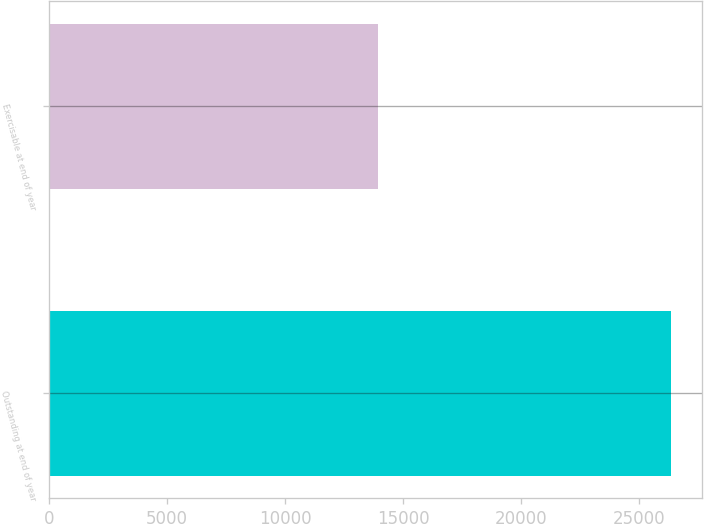Convert chart to OTSL. <chart><loc_0><loc_0><loc_500><loc_500><bar_chart><fcel>Outstanding at end of year<fcel>Exercisable at end of year<nl><fcel>26337<fcel>13940<nl></chart> 